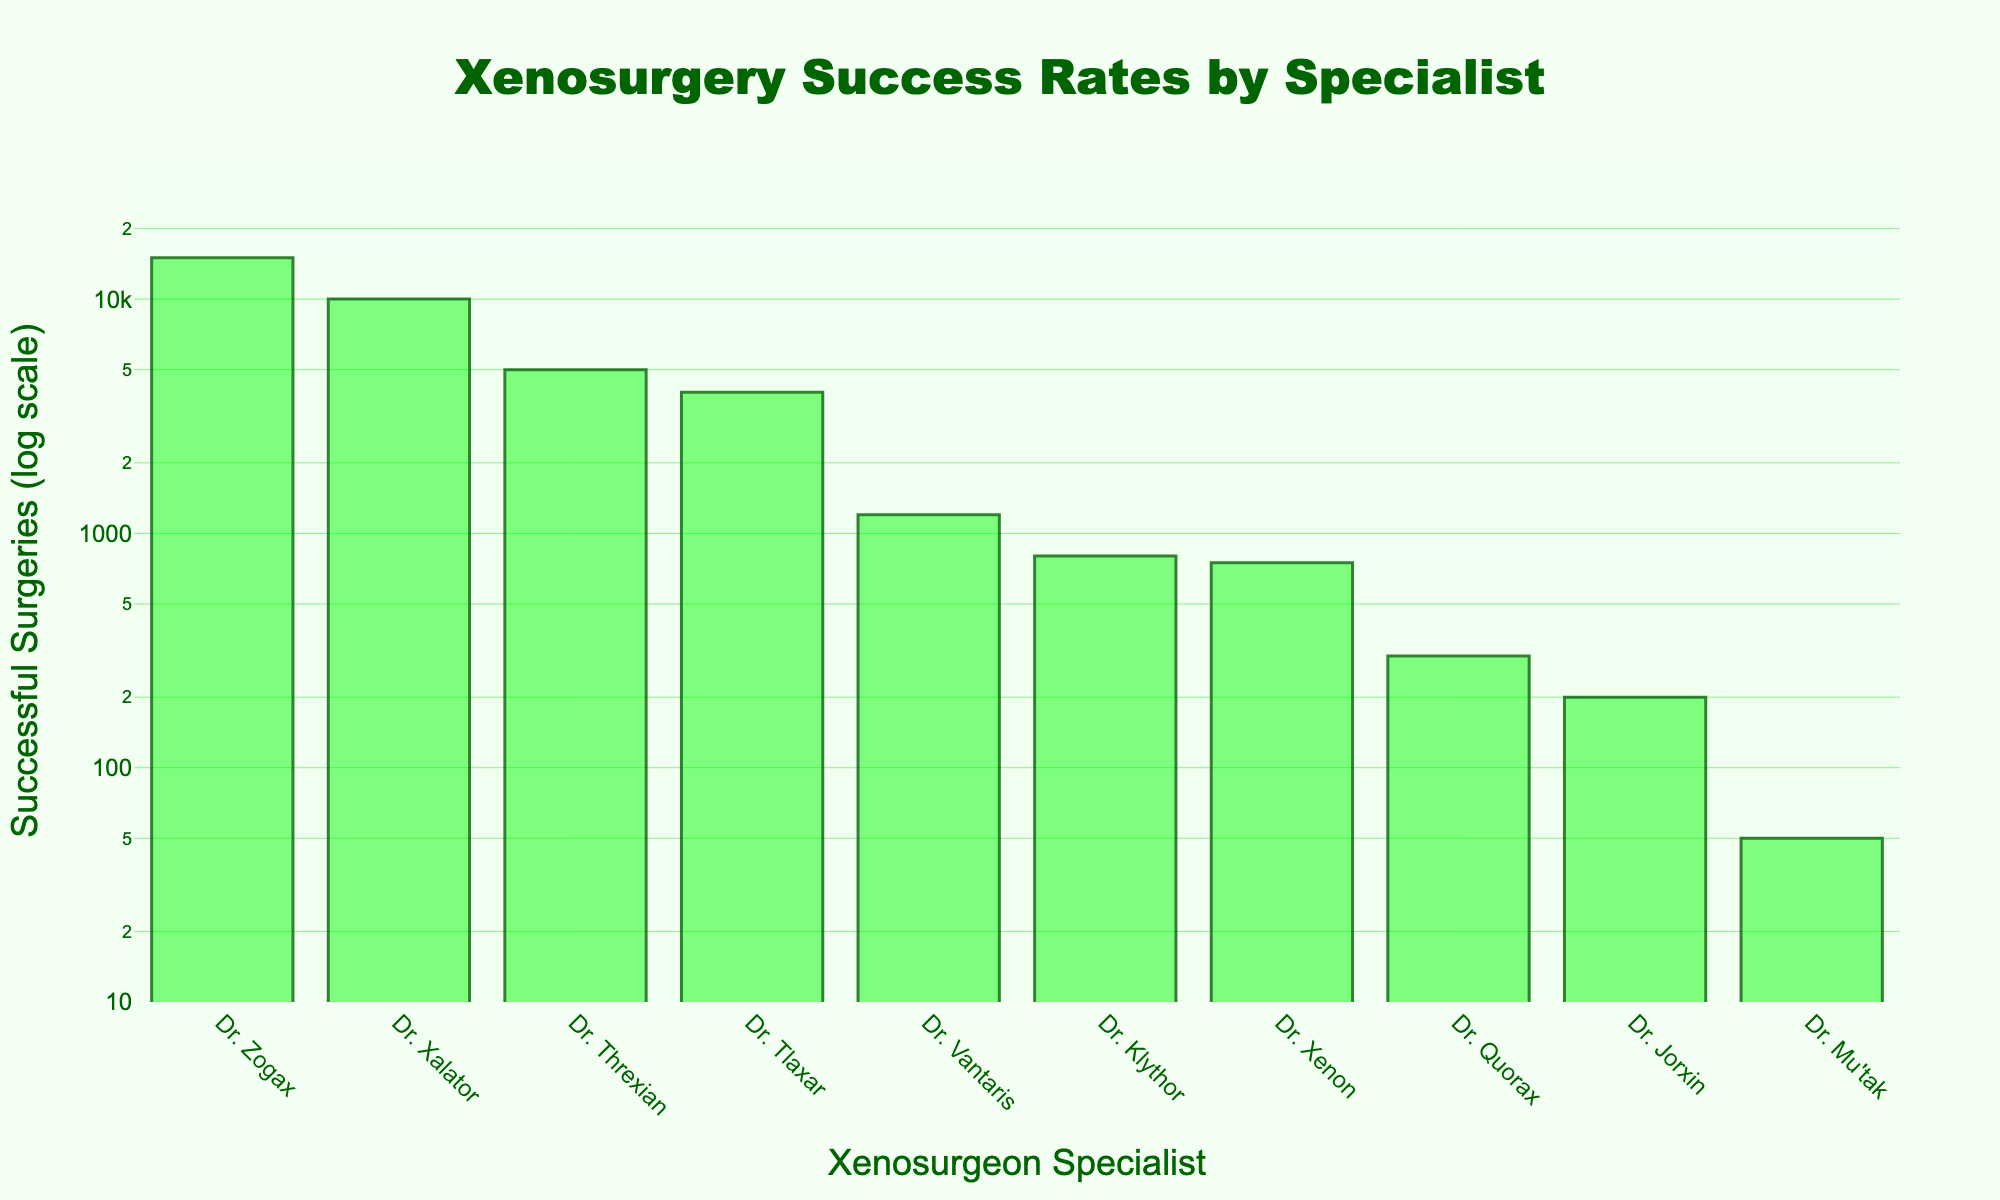Which xenosurgeon specialist has the highest number of successful surgeries? The y-axis represents the number of successful surgeries, and the bar corresponding to Dr. Zogax is the highest.
Answer: Dr. Zogax What is the title of the plot? The title of the plot is displayed at the top center of the figure.
Answer: Xenosurgery Success Rates by Specialist How many specialists are plotted on the x-axis? The x-axis ticks show all the specialists' names represented in the data. By counting them, we find there are 10 specialists.
Answer: 10 Which specialist has the fewest number of successful surgeries? The smallest bar on the y-axis corresponds to Dr. Mu'tak.
Answer: Dr. Mu'tak How do the successful surgeries of Dr. Klythor compare to Dr. Threxian? The height of the bars for Dr. Klythor and Dr. Threxian shows their successful surgeries. Dr. Threxian has a higher bar compared to Dr. Klythor, indicating more successful surgeries.
Answer: Dr. Threxian has more What is the approximate range of successful surgeries on the plot? By observing the y-axis, the plot ranges from the minimum (slightly above 10) represented by Dr. Mu'tak to the maximum (15,000) represented by Dr. Zogax.
Answer: ~10 to 15,000 How does the frequency of successful surgeries change towards the lower values in the log scale plot? Since the plot uses a log scale, the y-axis increments are not linear but logarithmic. This typically compresses higher values and expands lower values, showing a steeper gradient of decrease among the lower values.
Answer: It decreases rapidly Are the successful surgeries of Dr. Xenon closer in count to Dr. Jorxin or Dr. Quorax? By comparing the bar heights for Dr. Xenon, Dr. Jorxin, and Dr. Quorax, we see Dr. Xenon (750) is closer to Dr. Quorax (300) than to Dr. Jorxin (200).
Answer: Dr. Quorax What is the sum of the successful surgeries of Dr. Tlaxar and Dr. Vantaris? Dr. Tlaxar has 4000 and Dr. Vantaris has 1200 successful surgeries. Summing these figures gives 4000 + 1200 = 5200.
Answer: 5200 